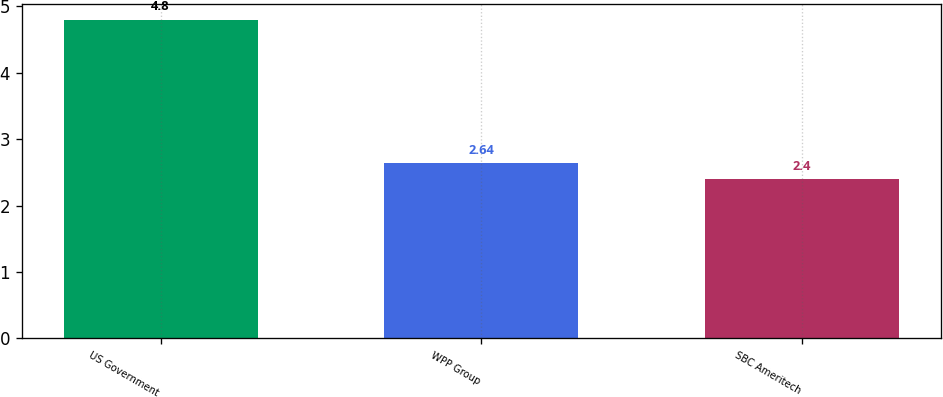<chart> <loc_0><loc_0><loc_500><loc_500><bar_chart><fcel>US Government<fcel>WPP Group<fcel>SBC Ameritech<nl><fcel>4.8<fcel>2.64<fcel>2.4<nl></chart> 